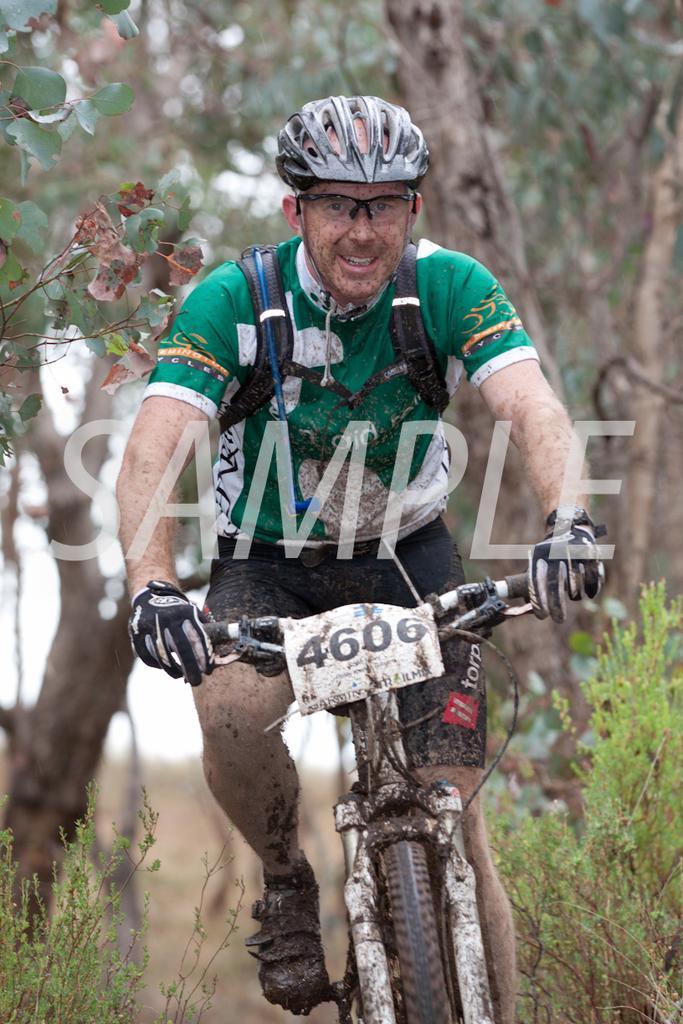In one or two sentences, can you explain what this image depicts? In this image there is a person wearing a helmet, goggles and riding a bicycle, there is a mud attached to the bicycle and the person's legs, there are a few plants and trees. 